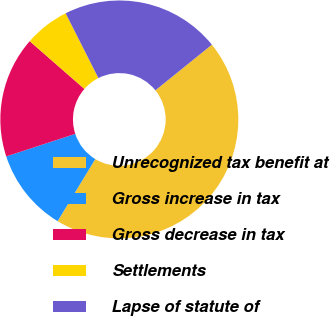<chart> <loc_0><loc_0><loc_500><loc_500><pie_chart><fcel>Unrecognized tax benefit at<fcel>Gross increase in tax<fcel>Gross decrease in tax<fcel>Settlements<fcel>Lapse of statute of<nl><fcel>44.49%<fcel>11.29%<fcel>16.46%<fcel>6.12%<fcel>21.64%<nl></chart> 